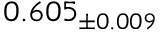<formula> <loc_0><loc_0><loc_500><loc_500>0 . 6 0 5 _ { \pm 0 . 0 0 9 }</formula> 